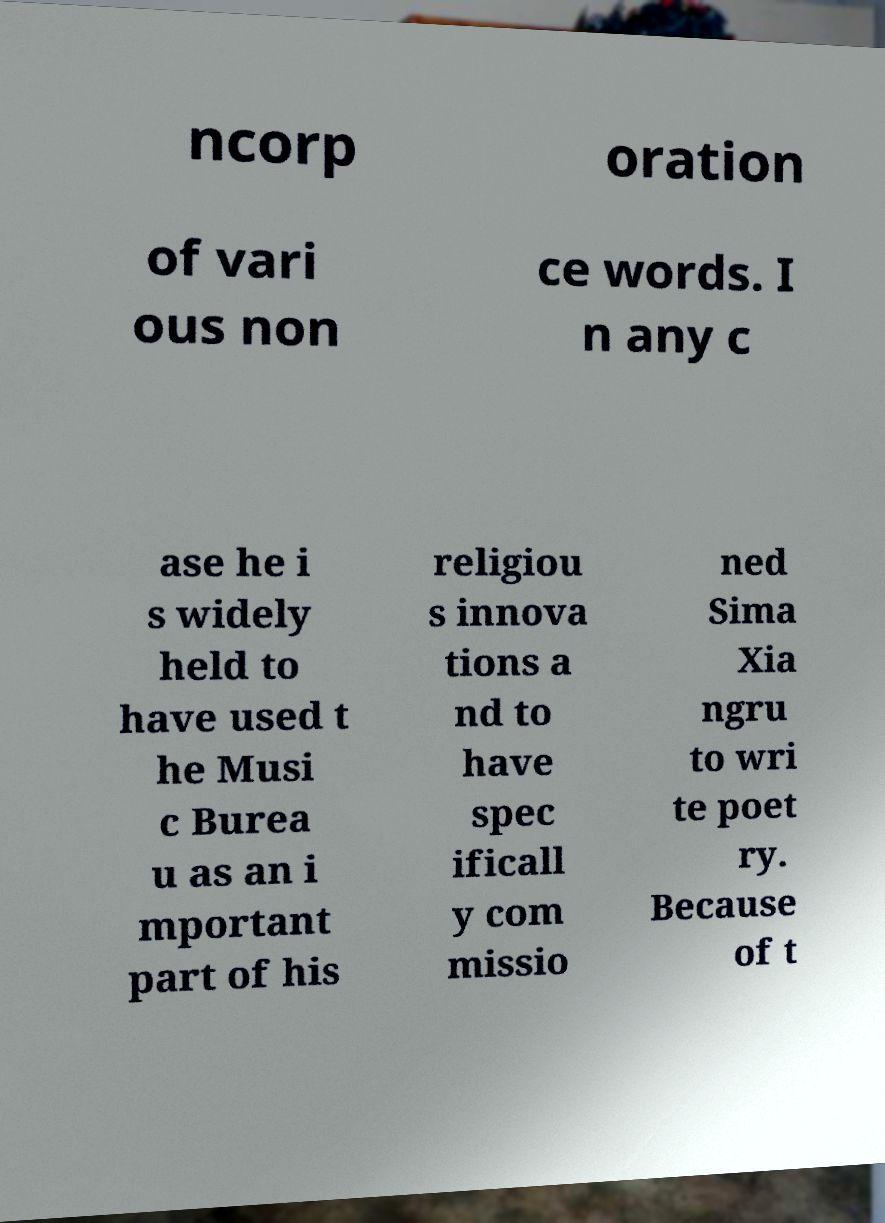Please read and relay the text visible in this image. What does it say? ncorp oration of vari ous non ce words. I n any c ase he i s widely held to have used t he Musi c Burea u as an i mportant part of his religiou s innova tions a nd to have spec ificall y com missio ned Sima Xia ngru to wri te poet ry. Because of t 